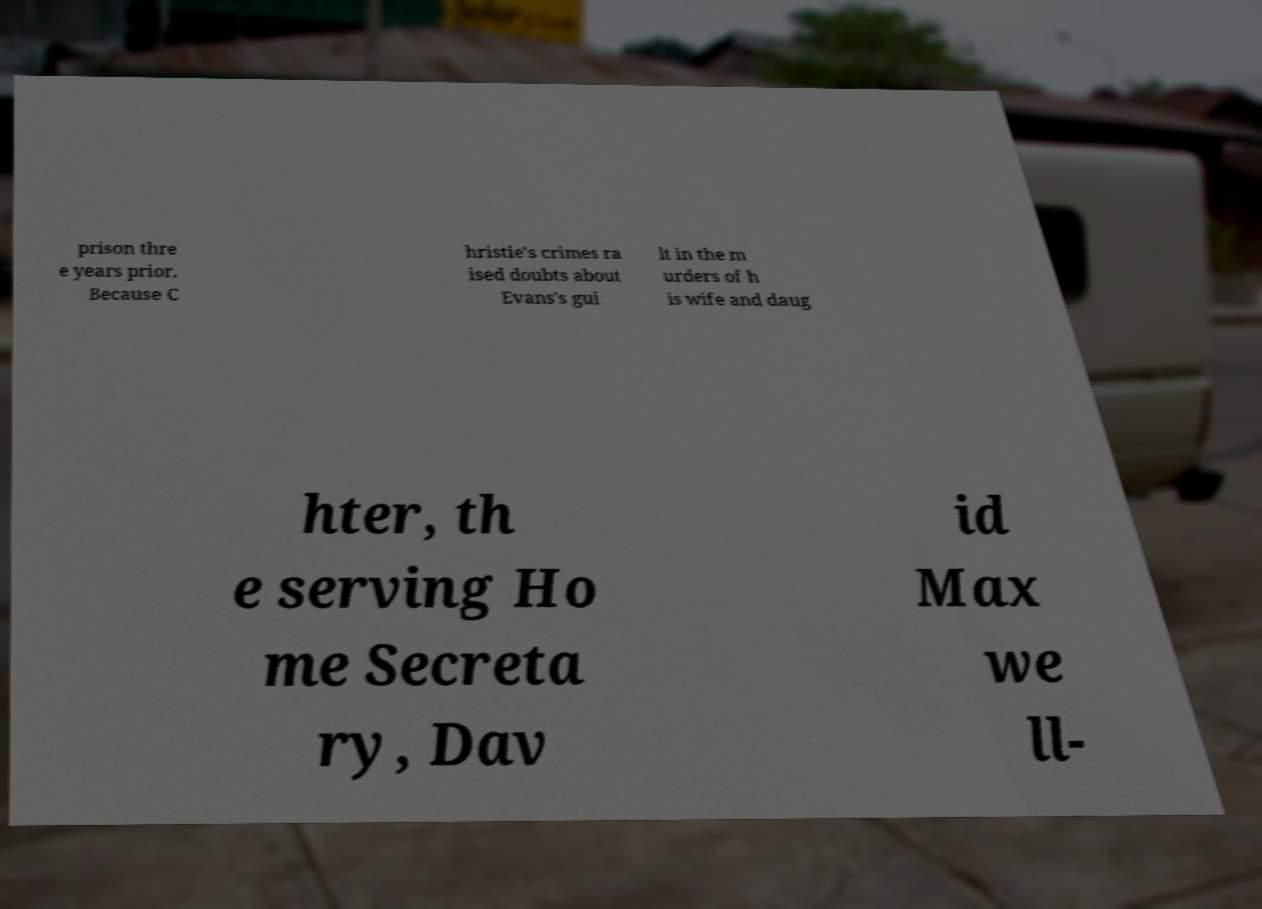Can you read and provide the text displayed in the image?This photo seems to have some interesting text. Can you extract and type it out for me? prison thre e years prior. Because C hristie's crimes ra ised doubts about Evans's gui lt in the m urders of h is wife and daug hter, th e serving Ho me Secreta ry, Dav id Max we ll- 